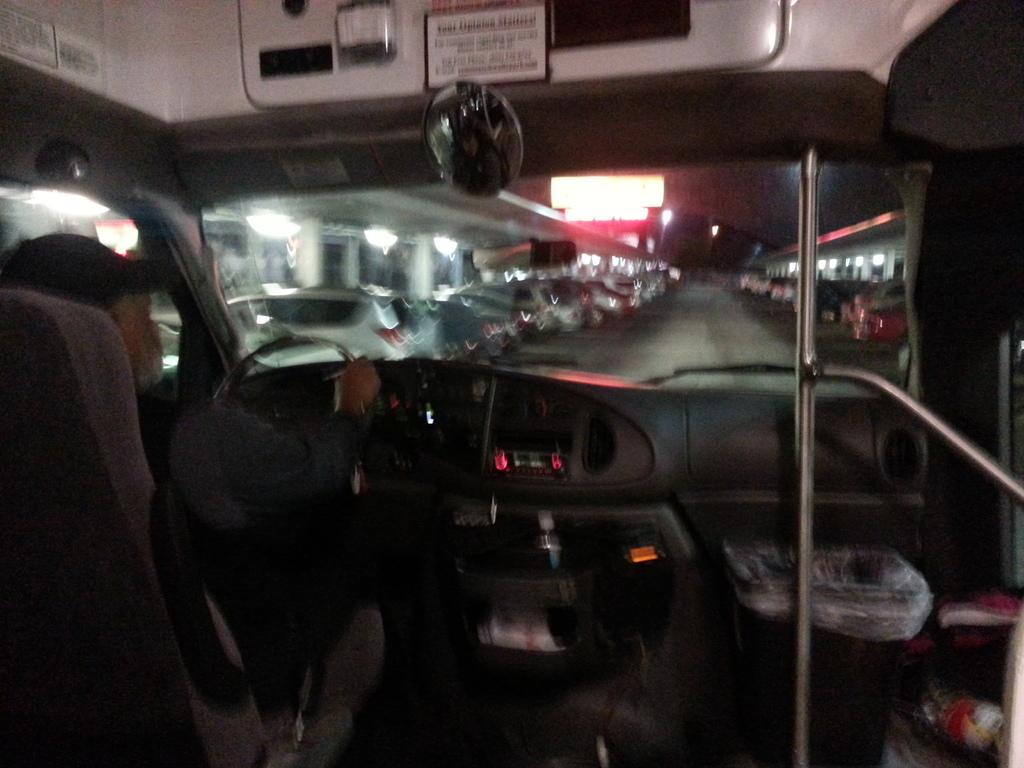Where was the image taken? The image was taken inside a vehicle. What is the location of the vehicle in the image? The vehicle is on a road. What can be seen on either side of the road in the image? There are cars on either side of the road. What type of ice can be seen melting on the dashboard in the image? There is no ice present in the image, and therefore no ice can be seen melting on the dashboard. 